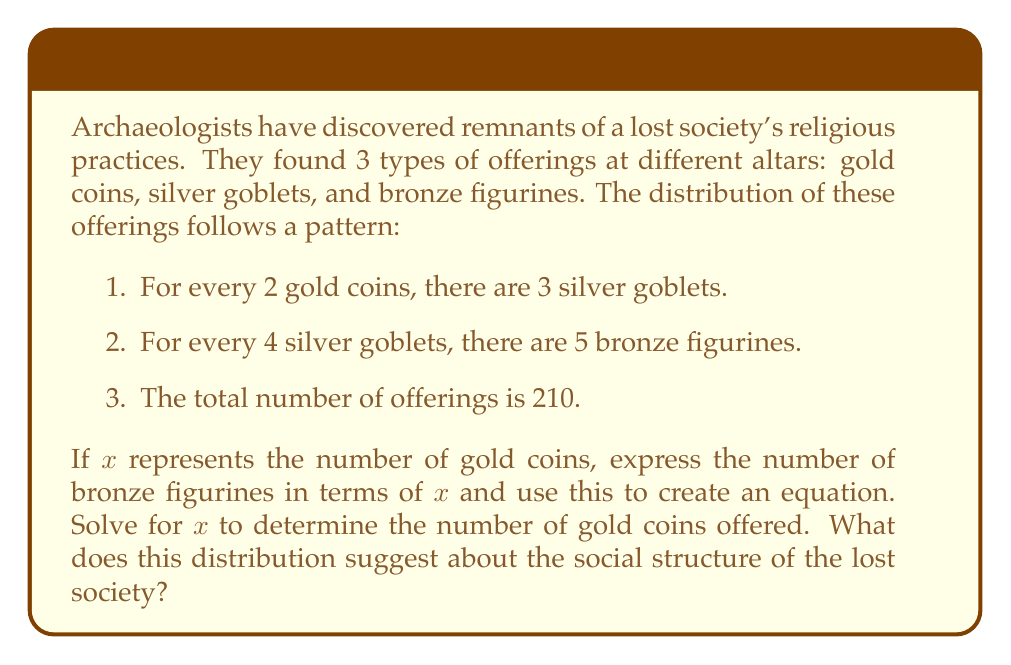Can you solve this math problem? Let's approach this step-by-step:

1) Let $x$ be the number of gold coins.

2) From the first condition, we can express silver goblets in terms of $x$:
   Silver goblets = $\frac{3}{2}x$

3) From the second condition, we can express bronze figurines in terms of silver goblets:
   Bronze figurines = $\frac{5}{4} \cdot \frac{3}{2}x = \frac{15}{8}x$

4) Now, we can set up an equation based on the total number of offerings:
   $x + \frac{3}{2}x + \frac{15}{8}x = 210$

5) Simplify the left side of the equation:
   $x(1 + \frac{3}{2} + \frac{15}{8}) = 210$
   $x(\frac{8}{8} + \frac{12}{8} + \frac{15}{8}) = 210$
   $x(\frac{35}{8}) = 210$

6) Solve for $x$:
   $x = 210 \cdot \frac{8}{35} = 48$

7) Therefore, there are 48 gold coins.

8) We can now calculate the other offerings:
   Silver goblets = $\frac{3}{2} \cdot 48 = 72$
   Bronze figurines = $\frac{15}{8} \cdot 48 = 90$

9) Interpretation: The distribution of offerings (48 gold, 72 silver, 90 bronze) suggests a hierarchical social structure. Gold, being the least common and most valuable, likely represents the elite class. Silver, more common than gold but less than bronze, could represent a middle class or priesthood. Bronze, the most common, likely represents the common people. This distribution implies a pyramid-like social structure with a small elite, a larger middle class, and the largest group being the common people.
Answer: 48 gold coins; pyramid-like social structure with small elite, larger middle class, largest common class. 